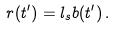Convert formula to latex. <formula><loc_0><loc_0><loc_500><loc_500>r ( t ^ { \prime } ) = l _ { s } b ( t ^ { \prime } ) \, .</formula> 